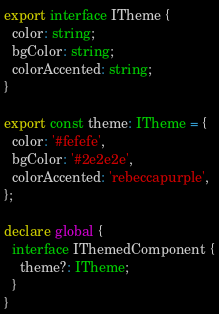Convert code to text. <code><loc_0><loc_0><loc_500><loc_500><_TypeScript_>export interface ITheme {
  color: string;
  bgColor: string;
  colorAccented: string;
}

export const theme: ITheme = {
  color: '#fefefe',
  bgColor: '#2e2e2e',
  colorAccented: 'rebeccapurple',
};

declare global {
  interface IThemedComponent {
    theme?: ITheme;
  }
}
</code> 